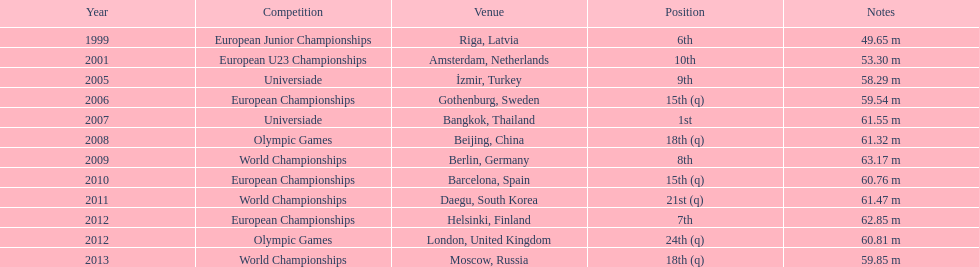How many world championships has he been in? 3. 